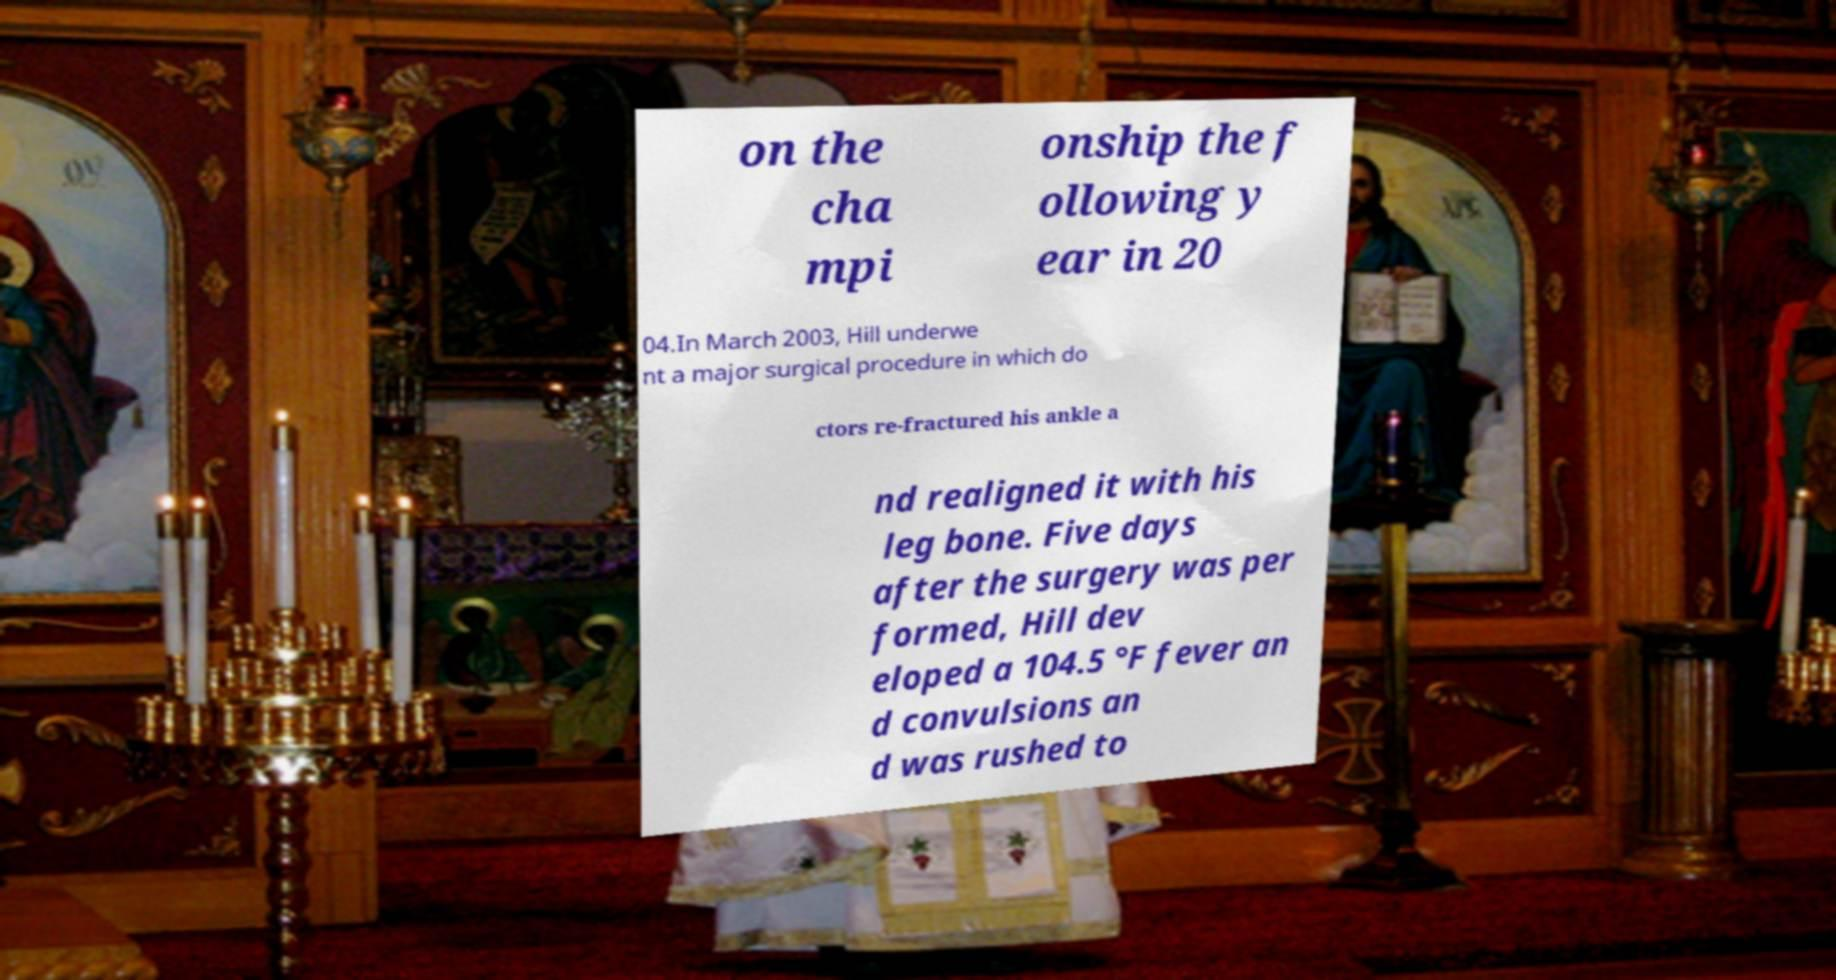For documentation purposes, I need the text within this image transcribed. Could you provide that? on the cha mpi onship the f ollowing y ear in 20 04.In March 2003, Hill underwe nt a major surgical procedure in which do ctors re-fractured his ankle a nd realigned it with his leg bone. Five days after the surgery was per formed, Hill dev eloped a 104.5 °F fever an d convulsions an d was rushed to 